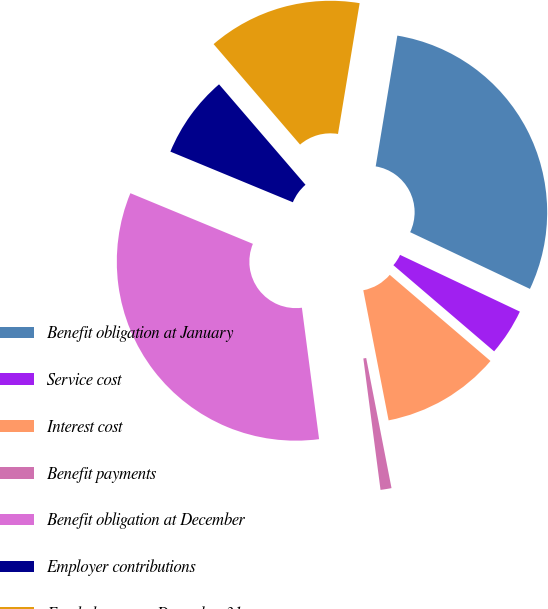Convert chart to OTSL. <chart><loc_0><loc_0><loc_500><loc_500><pie_chart><fcel>Benefit obligation at January<fcel>Service cost<fcel>Interest cost<fcel>Benefit payments<fcel>Benefit obligation at December<fcel>Employer contributions<fcel>Funded status at December 31 -<nl><fcel>29.43%<fcel>4.22%<fcel>10.68%<fcel>0.99%<fcel>33.31%<fcel>7.45%<fcel>13.92%<nl></chart> 